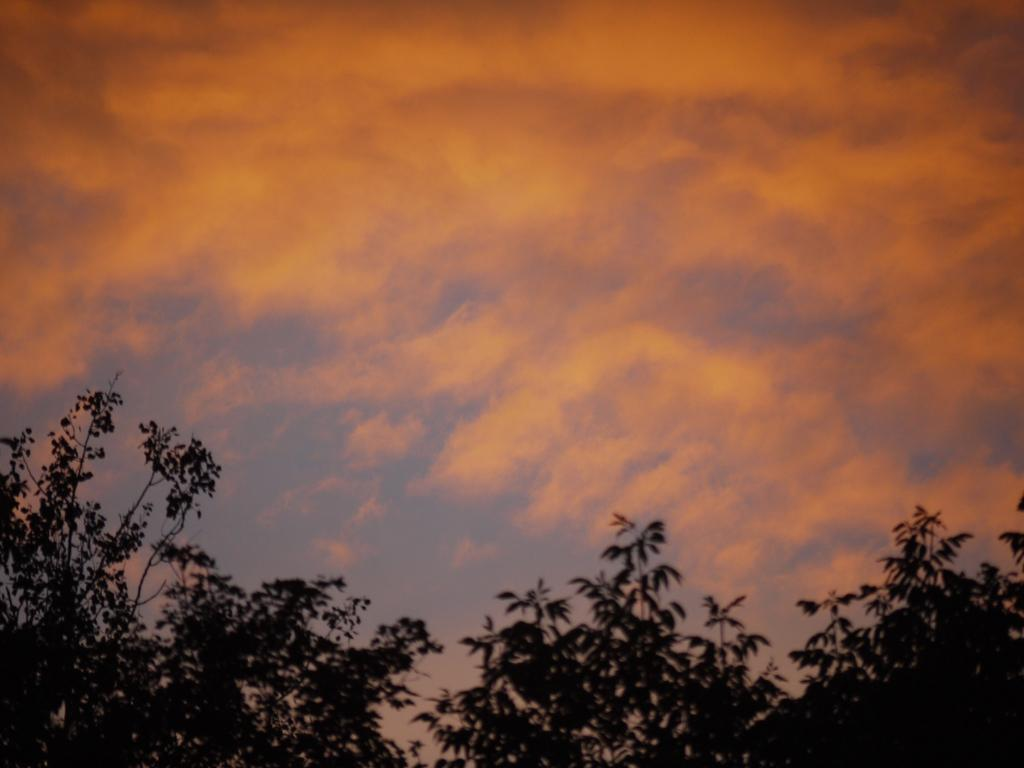What type of vegetation is visible at the bottom of the image? There are trees at the bottom side of the image. What is visible at the top of the image? There is sky at the top side of the image. What type of record can be seen in the image? There is no record present in the image. How does the grip of the trees affect the school in the image? There is no school present in the image, and the trees do not have a grip. 